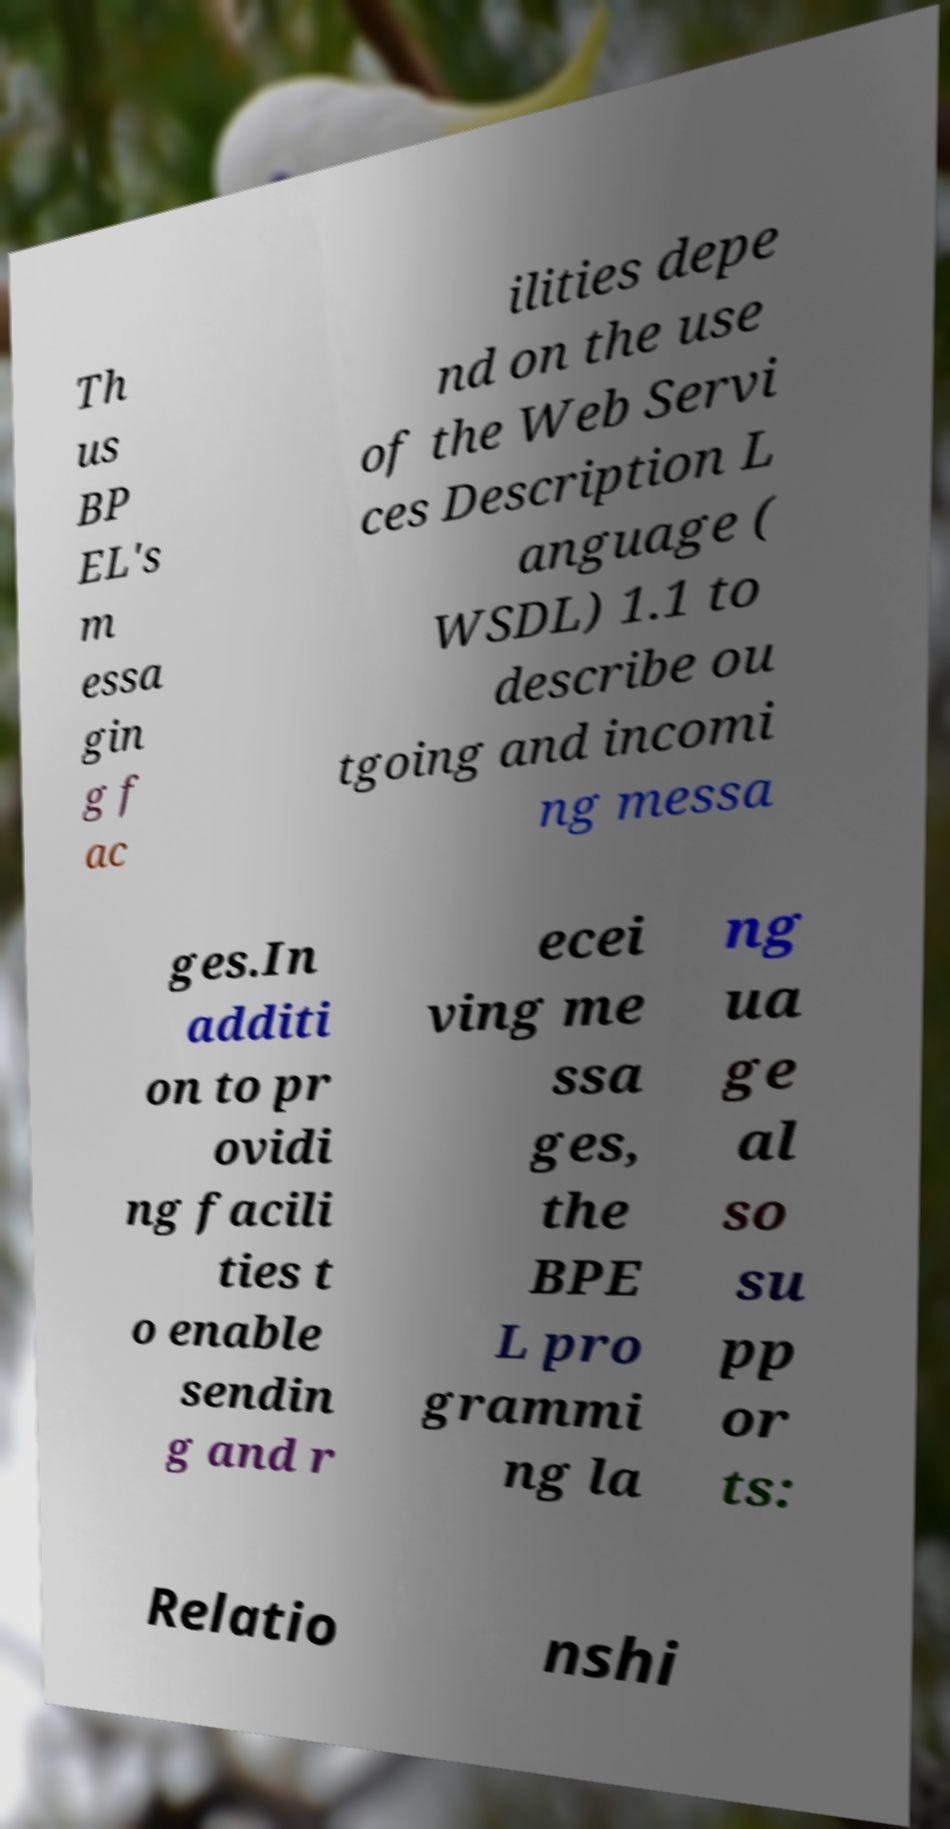What messages or text are displayed in this image? I need them in a readable, typed format. Th us BP EL's m essa gin g f ac ilities depe nd on the use of the Web Servi ces Description L anguage ( WSDL) 1.1 to describe ou tgoing and incomi ng messa ges.In additi on to pr ovidi ng facili ties t o enable sendin g and r ecei ving me ssa ges, the BPE L pro grammi ng la ng ua ge al so su pp or ts: Relatio nshi 